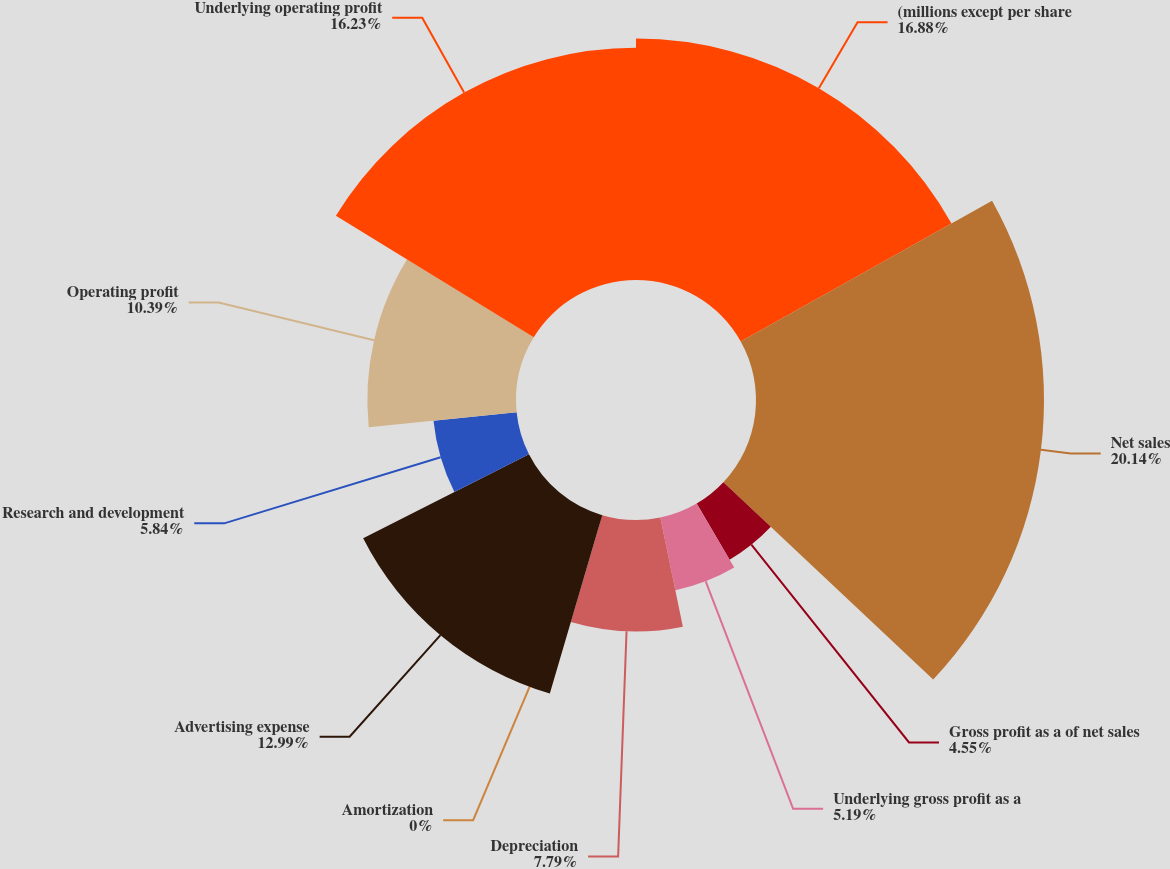Convert chart to OTSL. <chart><loc_0><loc_0><loc_500><loc_500><pie_chart><fcel>(millions except per share<fcel>Net sales<fcel>Gross profit as a of net sales<fcel>Underlying gross profit as a<fcel>Depreciation<fcel>Amortization<fcel>Advertising expense<fcel>Research and development<fcel>Operating profit<fcel>Underlying operating profit<nl><fcel>16.88%<fcel>20.13%<fcel>4.55%<fcel>5.19%<fcel>7.79%<fcel>0.0%<fcel>12.99%<fcel>5.84%<fcel>10.39%<fcel>16.23%<nl></chart> 